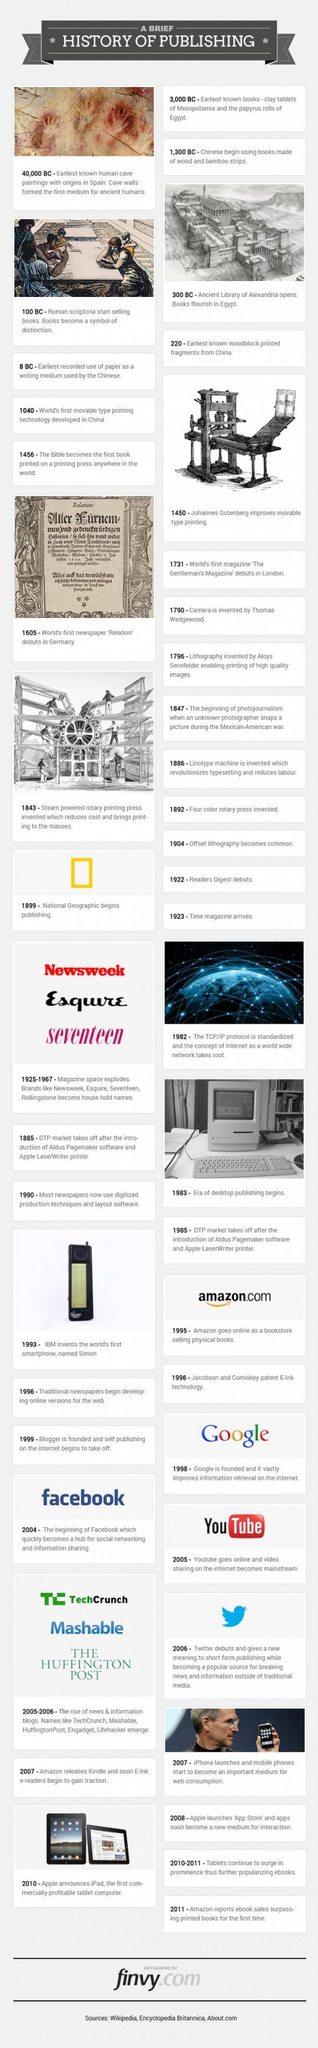Mention a couple of crucial points in this snapshot. The National Geographic logo is typically depicted in yellow, indicating its association with the iconic publication and its commitment to exploring and showcasing the natural world. 